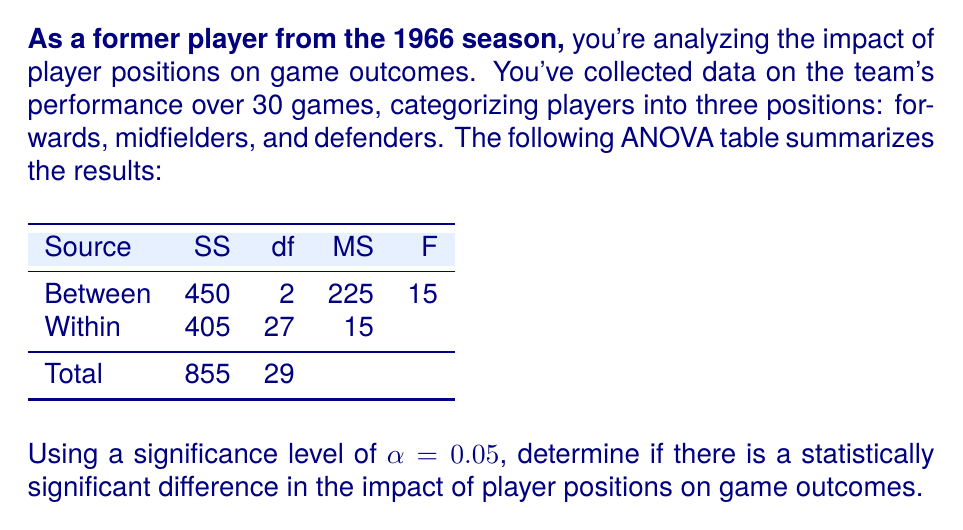Can you solve this math problem? To determine if there is a statistically significant difference in the impact of player positions on game outcomes, we need to follow these steps:

1. State the null and alternative hypotheses:
   $H_0$: There is no significant difference in the impact of player positions on game outcomes.
   $H_a$: There is a significant difference in the impact of player positions on game outcomes.

2. Identify the critical F-value:
   With α = 0.05, df_between = 2, and df_within = 27, we can look up the critical F-value in an F-distribution table or use a calculator. The critical F-value is approximately 3.35.

3. Calculate the F-statistic:
   The F-statistic is given in the ANOVA table as 15.

4. Compare the F-statistic to the critical F-value:
   Since the calculated F-statistic (15) is greater than the critical F-value (3.35), we reject the null hypothesis.

5. Interpret the results:
   Rejecting the null hypothesis means that there is strong evidence to suggest a statistically significant difference in the impact of player positions on game outcomes.

6. Calculate the p-value (optional):
   Using an F-distribution calculator with df_1 = 2 and df_2 = 27, we find that the p-value for F = 15 is approximately 0.000043, which is much smaller than α = 0.05, further confirming our decision to reject the null hypothesis.
Answer: Reject $H_0$; statistically significant difference in impact of player positions (F = 15 > F_crit = 3.35, p < 0.05) 